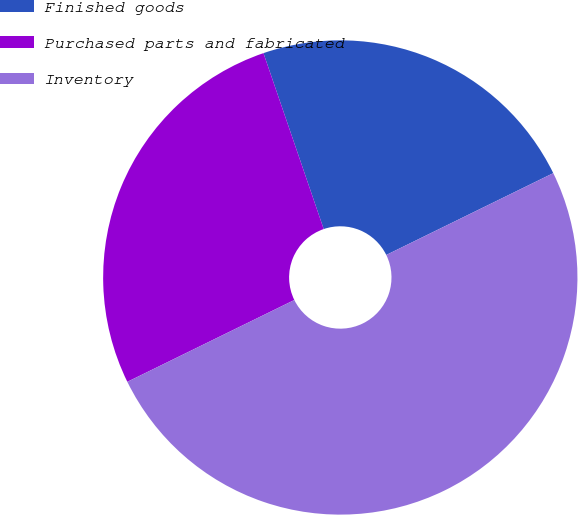Convert chart to OTSL. <chart><loc_0><loc_0><loc_500><loc_500><pie_chart><fcel>Finished goods<fcel>Purchased parts and fabricated<fcel>Inventory<nl><fcel>23.0%<fcel>27.0%<fcel>50.0%<nl></chart> 